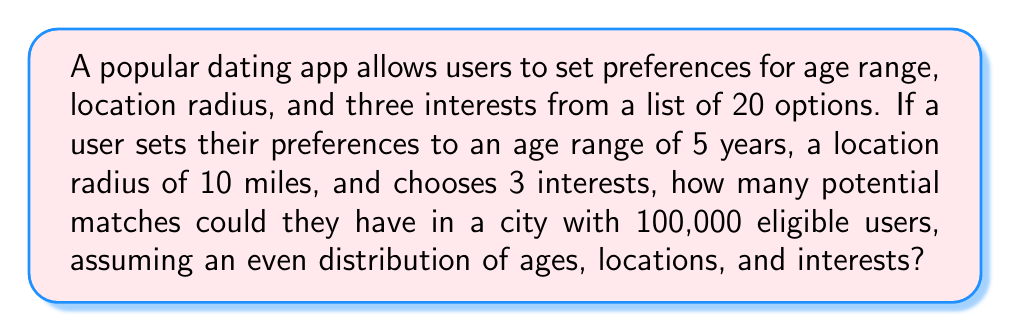What is the answer to this math problem? Let's break this down step-by-step:

1) Age range: 
   The user sets a 5-year age range out of a typical adult dating range (e.g., 18-65 years, which is 48 years).
   Probability of matching age: $\frac{5}{48} = \frac{5}{48}$

2) Location:
   Assume the city is circular with a radius of 20 miles.
   Area of the city: $\pi r^2 = \pi (20)^2 = 400\pi$ sq miles
   Area of user's search: $\pi r^2 = \pi (10)^2 = 100\pi$ sq miles
   Probability of matching location: $\frac{100\pi}{400\pi} = \frac{1}{4}$

3) Interests:
   The user chooses 3 out of 20 interests.
   Probability of matching all 3 interests: $(\frac{3}{20})^3 = \frac{27}{8000}$

4) Combining probabilities:
   Probability of a user meeting all criteria:
   $$\frac{5}{48} \times \frac{1}{4} \times \frac{27}{8000} = \frac{135}{1,536,000}$$

5) Number of potential matches:
   $$100,000 \times \frac{135}{1,536,000} = \frac{13,500}{1,536} \approx 8.79$$

Therefore, the expected number of matches is approximately 9 users.
Answer: 9 potential matches 